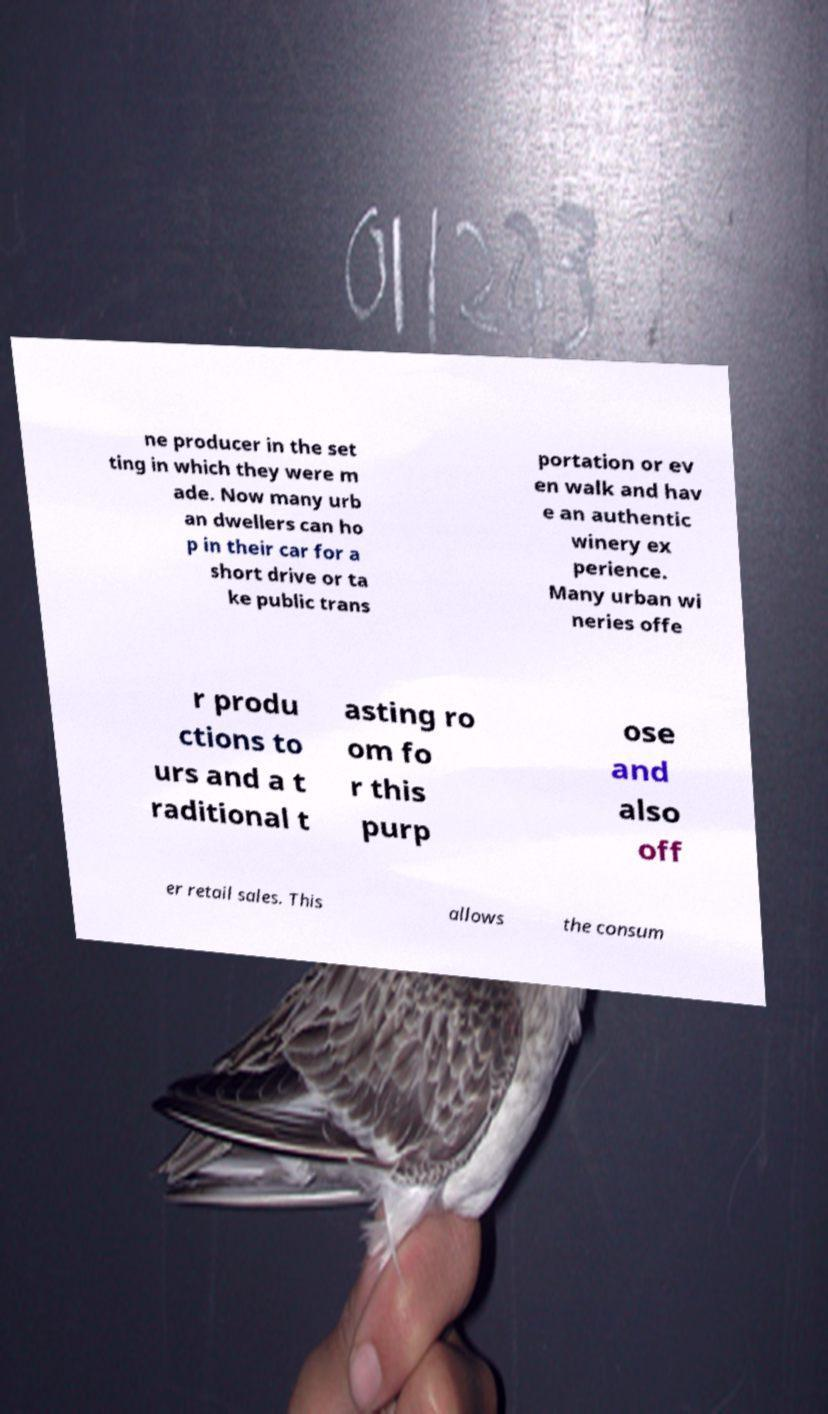Please read and relay the text visible in this image. What does it say? ne producer in the set ting in which they were m ade. Now many urb an dwellers can ho p in their car for a short drive or ta ke public trans portation or ev en walk and hav e an authentic winery ex perience. Many urban wi neries offe r produ ctions to urs and a t raditional t asting ro om fo r this purp ose and also off er retail sales. This allows the consum 